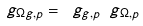<formula> <loc_0><loc_0><loc_500><loc_500>\ g _ { \Omega g , p } = \ g _ { g , p } \ g _ { \Omega , p }</formula> 